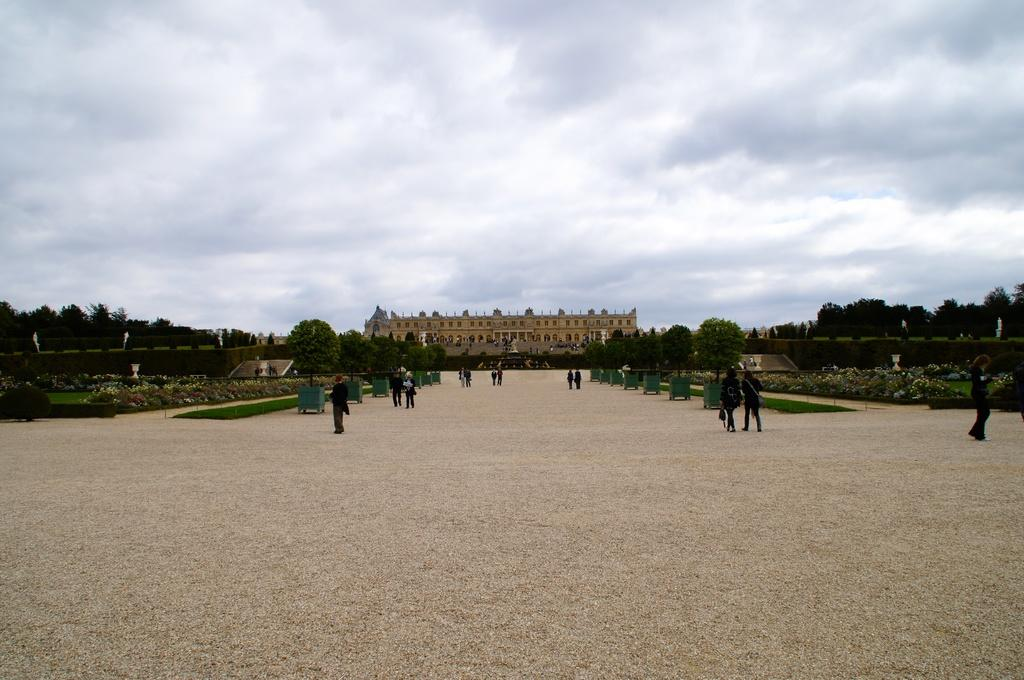What is the main subject of the image? The main subject of the image is a group of people standing on the ground. What can be seen beside the people? There are trees beside the people. What is located at the back of the image? There is a building at the back of the image. What is the price of the marble statue in the image? There is no marble statue present in the image. 